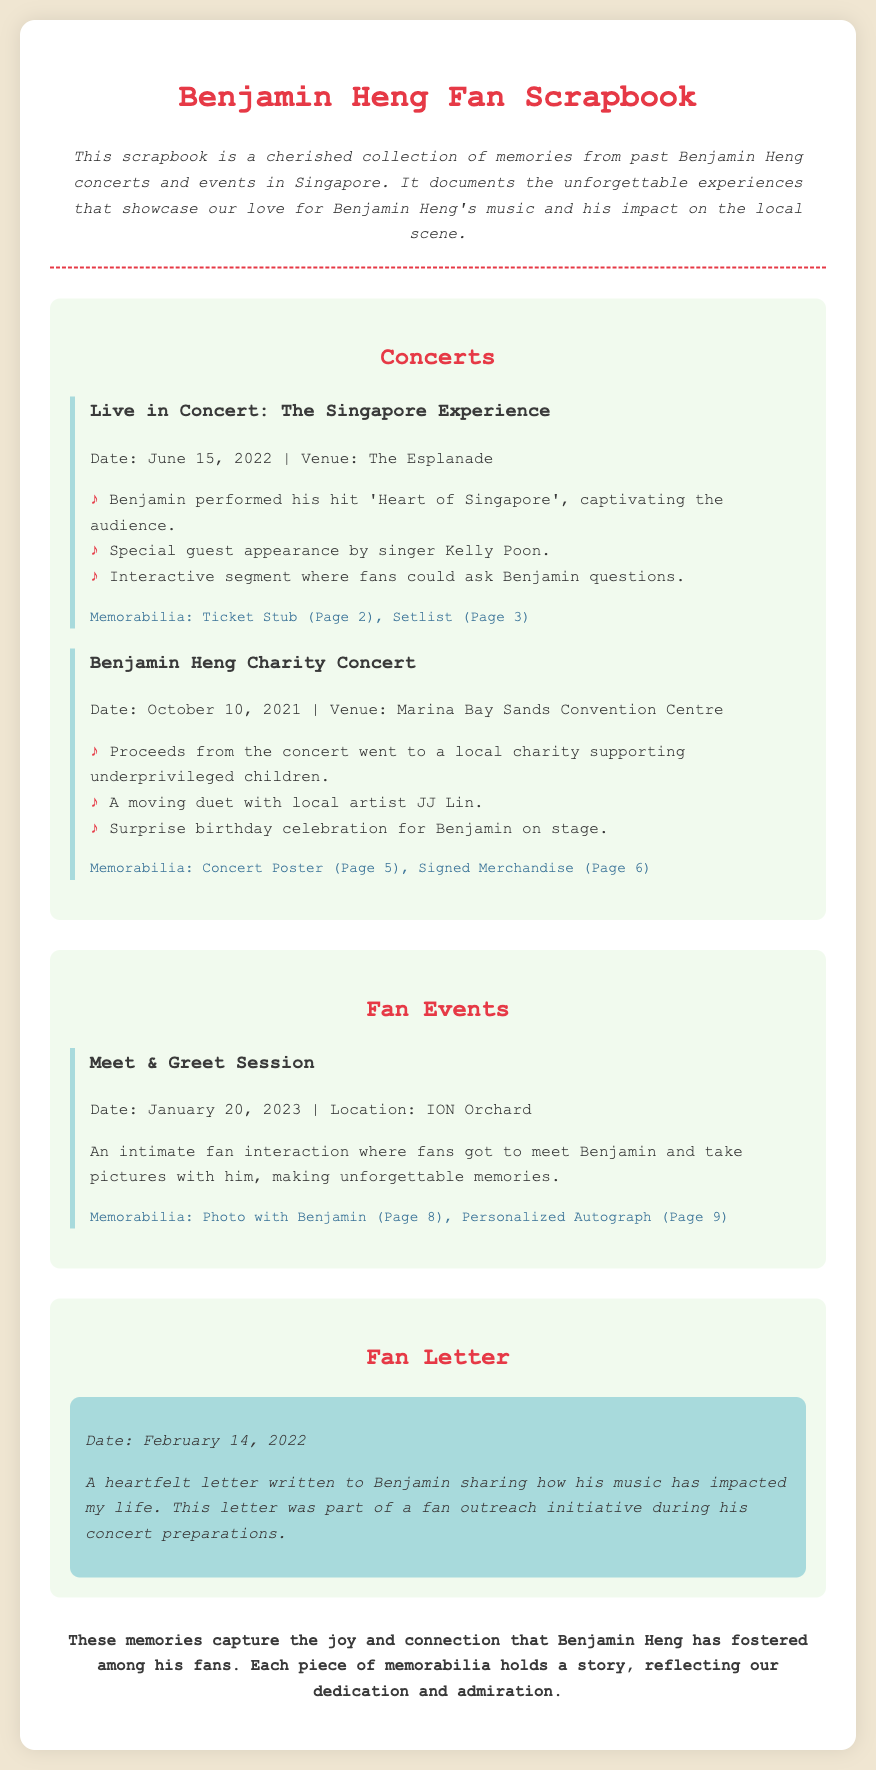What is the title of the scrapbook? The title of the scrapbook, as stated in the document, is "Benjamin Heng Fan Scrapbook."
Answer: Benjamin Heng Fan Scrapbook When did the concert "Live in Concert: The Singapore Experience" take place? The document clearly mentions that the concert took place on June 15, 2022.
Answer: June 15, 2022 What was one highlight of the Benjamin Heng Charity Concert? The document lists several highlights, one of which is a moving duet with local artist JJ Lin.
Answer: A moving duet with local artist JJ Lin Which venue hosted the Meet & Greet Session? The document indicates that the Meet & Greet Session was held at ION Orchard.
Answer: ION Orchard What did fans receive as memorabilia from the "Live in Concert: The Singapore Experience"? According to the document, fans received a Ticket Stub and Setlist as memorabilia from that event.
Answer: Ticket Stub, Setlist What type of letter was included in the scrapbook? The document specifies that it is a heartfelt letter written to Benjamin.
Answer: Heartfelt letter Why did the proceeds from the Benjamin Heng Charity Concert go to charity? The document states that the proceeds went to support underprivileged children.
Answer: To support underprivileged children On what date was the fan letter written? The document provides the date that the letter was written as February 14, 2022.
Answer: February 14, 2022 